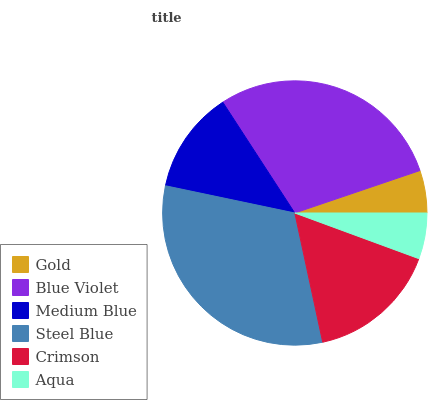Is Gold the minimum?
Answer yes or no. Yes. Is Steel Blue the maximum?
Answer yes or no. Yes. Is Blue Violet the minimum?
Answer yes or no. No. Is Blue Violet the maximum?
Answer yes or no. No. Is Blue Violet greater than Gold?
Answer yes or no. Yes. Is Gold less than Blue Violet?
Answer yes or no. Yes. Is Gold greater than Blue Violet?
Answer yes or no. No. Is Blue Violet less than Gold?
Answer yes or no. No. Is Crimson the high median?
Answer yes or no. Yes. Is Medium Blue the low median?
Answer yes or no. Yes. Is Medium Blue the high median?
Answer yes or no. No. Is Crimson the low median?
Answer yes or no. No. 